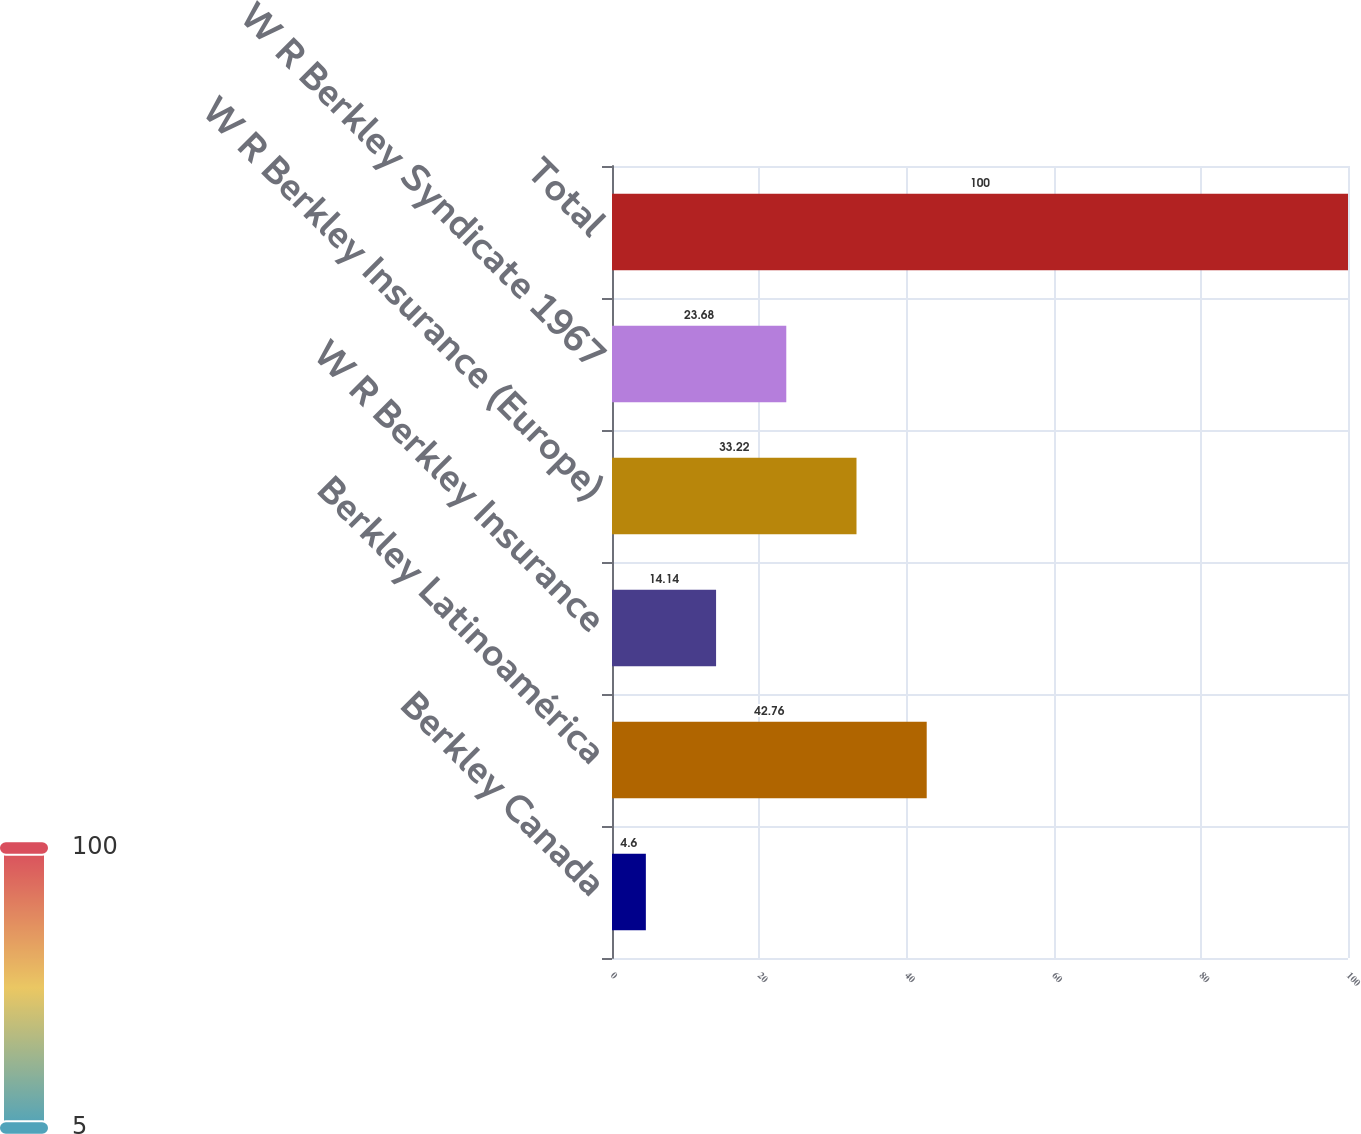Convert chart. <chart><loc_0><loc_0><loc_500><loc_500><bar_chart><fcel>Berkley Canada<fcel>Berkley Latinoamérica<fcel>W R Berkley Insurance<fcel>W R Berkley Insurance (Europe)<fcel>W R Berkley Syndicate 1967<fcel>Total<nl><fcel>4.6<fcel>42.76<fcel>14.14<fcel>33.22<fcel>23.68<fcel>100<nl></chart> 